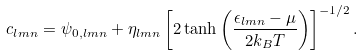Convert formula to latex. <formula><loc_0><loc_0><loc_500><loc_500>c _ { l m n } & = \psi _ { 0 , l m n } + \eta _ { l m n } \left [ 2 \tanh { \left ( \frac { \epsilon _ { l m n } - \mu } { 2 k _ { B } T } \right ) } \right ] ^ { - 1 / 2 } .</formula> 